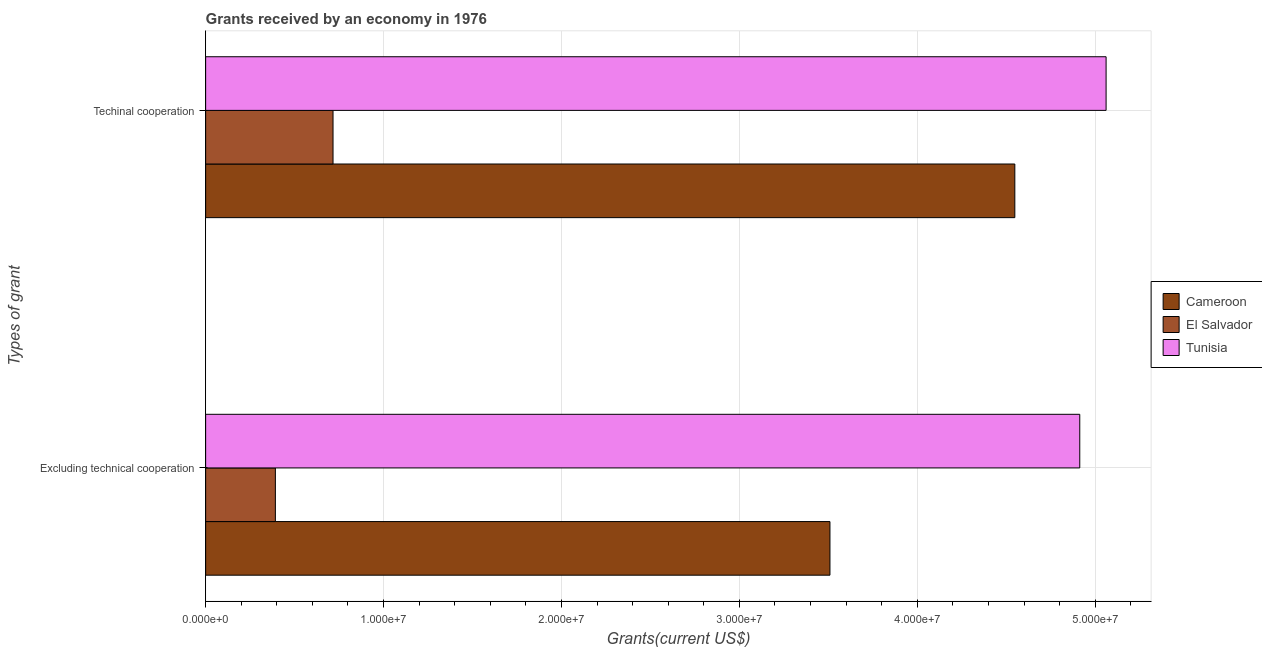How many different coloured bars are there?
Your answer should be compact. 3. How many groups of bars are there?
Provide a short and direct response. 2. Are the number of bars per tick equal to the number of legend labels?
Your answer should be very brief. Yes. How many bars are there on the 1st tick from the top?
Offer a terse response. 3. How many bars are there on the 2nd tick from the bottom?
Provide a short and direct response. 3. What is the label of the 1st group of bars from the top?
Give a very brief answer. Techinal cooperation. What is the amount of grants received(excluding technical cooperation) in Tunisia?
Offer a very short reply. 4.91e+07. Across all countries, what is the maximum amount of grants received(including technical cooperation)?
Give a very brief answer. 5.06e+07. Across all countries, what is the minimum amount of grants received(including technical cooperation)?
Offer a very short reply. 7.16e+06. In which country was the amount of grants received(excluding technical cooperation) maximum?
Make the answer very short. Tunisia. In which country was the amount of grants received(excluding technical cooperation) minimum?
Provide a succinct answer. El Salvador. What is the total amount of grants received(including technical cooperation) in the graph?
Provide a short and direct response. 1.03e+08. What is the difference between the amount of grants received(including technical cooperation) in Tunisia and that in El Salvador?
Your response must be concise. 4.34e+07. What is the difference between the amount of grants received(including technical cooperation) in Cameroon and the amount of grants received(excluding technical cooperation) in Tunisia?
Offer a very short reply. -3.65e+06. What is the average amount of grants received(including technical cooperation) per country?
Ensure brevity in your answer.  3.44e+07. What is the difference between the amount of grants received(including technical cooperation) and amount of grants received(excluding technical cooperation) in Tunisia?
Your answer should be very brief. 1.48e+06. What is the ratio of the amount of grants received(excluding technical cooperation) in El Salvador to that in Cameroon?
Keep it short and to the point. 0.11. Is the amount of grants received(including technical cooperation) in El Salvador less than that in Cameroon?
Offer a very short reply. Yes. In how many countries, is the amount of grants received(excluding technical cooperation) greater than the average amount of grants received(excluding technical cooperation) taken over all countries?
Offer a terse response. 2. What does the 2nd bar from the top in Excluding technical cooperation represents?
Provide a succinct answer. El Salvador. What does the 1st bar from the bottom in Excluding technical cooperation represents?
Your answer should be very brief. Cameroon. Are all the bars in the graph horizontal?
Offer a very short reply. Yes. How many countries are there in the graph?
Make the answer very short. 3. Does the graph contain grids?
Your answer should be compact. Yes. How are the legend labels stacked?
Provide a succinct answer. Vertical. What is the title of the graph?
Your answer should be very brief. Grants received by an economy in 1976. What is the label or title of the X-axis?
Provide a succinct answer. Grants(current US$). What is the label or title of the Y-axis?
Ensure brevity in your answer.  Types of grant. What is the Grants(current US$) in Cameroon in Excluding technical cooperation?
Offer a terse response. 3.51e+07. What is the Grants(current US$) in El Salvador in Excluding technical cooperation?
Keep it short and to the point. 3.92e+06. What is the Grants(current US$) of Tunisia in Excluding technical cooperation?
Give a very brief answer. 4.91e+07. What is the Grants(current US$) of Cameroon in Techinal cooperation?
Your answer should be compact. 4.55e+07. What is the Grants(current US$) in El Salvador in Techinal cooperation?
Your answer should be compact. 7.16e+06. What is the Grants(current US$) of Tunisia in Techinal cooperation?
Give a very brief answer. 5.06e+07. Across all Types of grant, what is the maximum Grants(current US$) in Cameroon?
Your response must be concise. 4.55e+07. Across all Types of grant, what is the maximum Grants(current US$) of El Salvador?
Offer a very short reply. 7.16e+06. Across all Types of grant, what is the maximum Grants(current US$) of Tunisia?
Make the answer very short. 5.06e+07. Across all Types of grant, what is the minimum Grants(current US$) in Cameroon?
Your answer should be compact. 3.51e+07. Across all Types of grant, what is the minimum Grants(current US$) in El Salvador?
Give a very brief answer. 3.92e+06. Across all Types of grant, what is the minimum Grants(current US$) of Tunisia?
Make the answer very short. 4.91e+07. What is the total Grants(current US$) of Cameroon in the graph?
Your answer should be very brief. 8.06e+07. What is the total Grants(current US$) of El Salvador in the graph?
Offer a terse response. 1.11e+07. What is the total Grants(current US$) in Tunisia in the graph?
Your answer should be very brief. 9.97e+07. What is the difference between the Grants(current US$) of Cameroon in Excluding technical cooperation and that in Techinal cooperation?
Your answer should be very brief. -1.04e+07. What is the difference between the Grants(current US$) in El Salvador in Excluding technical cooperation and that in Techinal cooperation?
Keep it short and to the point. -3.24e+06. What is the difference between the Grants(current US$) of Tunisia in Excluding technical cooperation and that in Techinal cooperation?
Provide a succinct answer. -1.48e+06. What is the difference between the Grants(current US$) of Cameroon in Excluding technical cooperation and the Grants(current US$) of El Salvador in Techinal cooperation?
Your answer should be compact. 2.79e+07. What is the difference between the Grants(current US$) in Cameroon in Excluding technical cooperation and the Grants(current US$) in Tunisia in Techinal cooperation?
Your response must be concise. -1.55e+07. What is the difference between the Grants(current US$) in El Salvador in Excluding technical cooperation and the Grants(current US$) in Tunisia in Techinal cooperation?
Provide a short and direct response. -4.67e+07. What is the average Grants(current US$) in Cameroon per Types of grant?
Provide a short and direct response. 4.03e+07. What is the average Grants(current US$) in El Salvador per Types of grant?
Your response must be concise. 5.54e+06. What is the average Grants(current US$) of Tunisia per Types of grant?
Your answer should be compact. 4.99e+07. What is the difference between the Grants(current US$) of Cameroon and Grants(current US$) of El Salvador in Excluding technical cooperation?
Your response must be concise. 3.12e+07. What is the difference between the Grants(current US$) of Cameroon and Grants(current US$) of Tunisia in Excluding technical cooperation?
Keep it short and to the point. -1.40e+07. What is the difference between the Grants(current US$) of El Salvador and Grants(current US$) of Tunisia in Excluding technical cooperation?
Offer a terse response. -4.52e+07. What is the difference between the Grants(current US$) of Cameroon and Grants(current US$) of El Salvador in Techinal cooperation?
Provide a short and direct response. 3.83e+07. What is the difference between the Grants(current US$) of Cameroon and Grants(current US$) of Tunisia in Techinal cooperation?
Provide a succinct answer. -5.13e+06. What is the difference between the Grants(current US$) of El Salvador and Grants(current US$) of Tunisia in Techinal cooperation?
Offer a very short reply. -4.34e+07. What is the ratio of the Grants(current US$) in Cameroon in Excluding technical cooperation to that in Techinal cooperation?
Offer a very short reply. 0.77. What is the ratio of the Grants(current US$) of El Salvador in Excluding technical cooperation to that in Techinal cooperation?
Your response must be concise. 0.55. What is the ratio of the Grants(current US$) of Tunisia in Excluding technical cooperation to that in Techinal cooperation?
Keep it short and to the point. 0.97. What is the difference between the highest and the second highest Grants(current US$) in Cameroon?
Give a very brief answer. 1.04e+07. What is the difference between the highest and the second highest Grants(current US$) in El Salvador?
Ensure brevity in your answer.  3.24e+06. What is the difference between the highest and the second highest Grants(current US$) in Tunisia?
Offer a terse response. 1.48e+06. What is the difference between the highest and the lowest Grants(current US$) in Cameroon?
Give a very brief answer. 1.04e+07. What is the difference between the highest and the lowest Grants(current US$) in El Salvador?
Ensure brevity in your answer.  3.24e+06. What is the difference between the highest and the lowest Grants(current US$) of Tunisia?
Your answer should be very brief. 1.48e+06. 